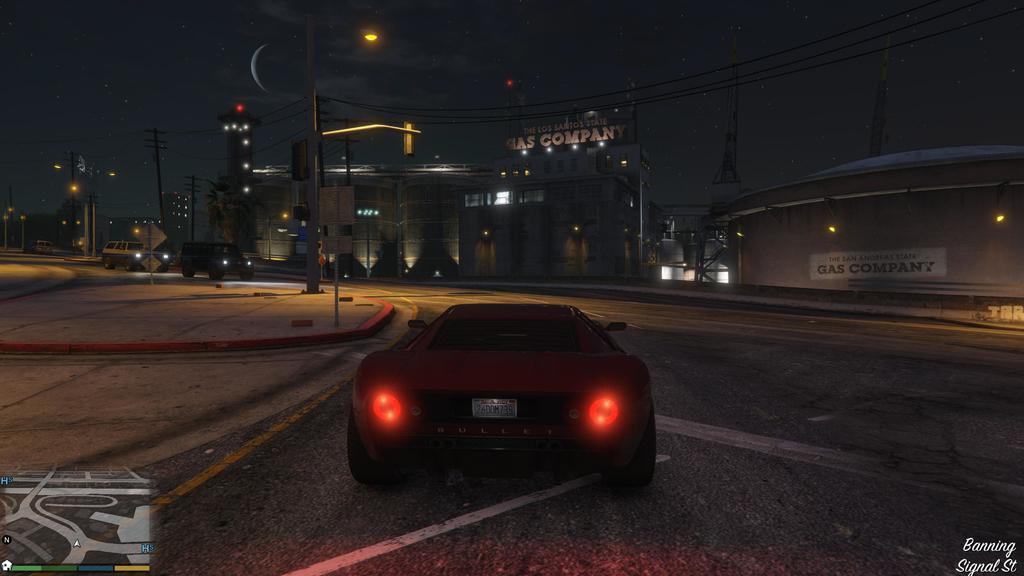Describe this image in one or two sentences. In the center of the image, we can see a car on the road and in the background, there are poles along with wires, buildings and some vehicles on the road. 